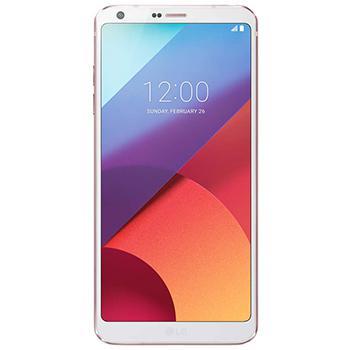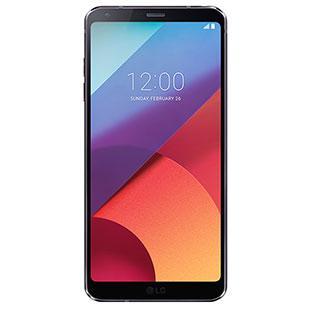The first image is the image on the left, the second image is the image on the right. For the images displayed, is the sentence "there are two phones in the image pair" factually correct? Answer yes or no. Yes. The first image is the image on the left, the second image is the image on the right. Considering the images on both sides, is "There are no more than 2 phones." valid? Answer yes or no. Yes. 